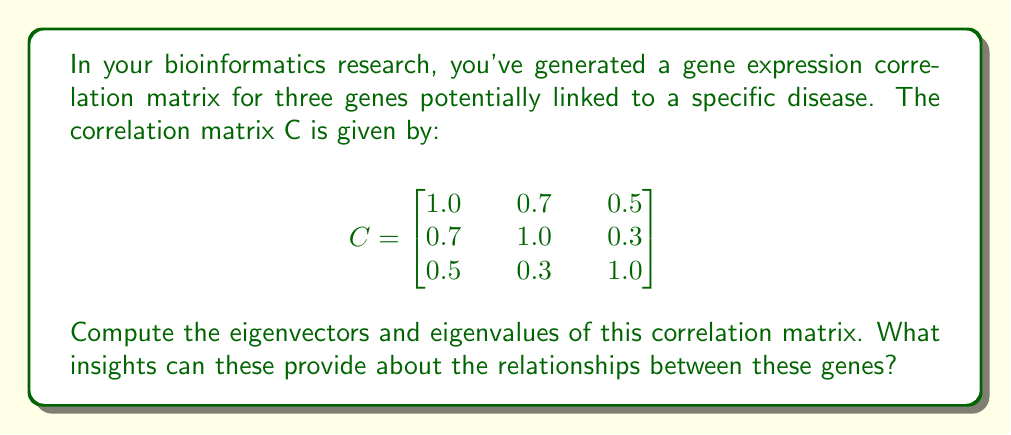Can you answer this question? To find the eigenvectors and eigenvalues of the correlation matrix C, we follow these steps:

1) First, we need to solve the characteristic equation:
   $$\det(C - \lambda I) = 0$$
   
   Where I is the 3x3 identity matrix and λ represents the eigenvalues.

2) Expanding the determinant:
   $$\begin{vmatrix}
   1-\lambda & 0.7 & 0.5 \\
   0.7 & 1-\lambda & 0.3 \\
   0.5 & 0.3 & 1-\lambda
   \end{vmatrix} = 0$$

3) This gives us the characteristic polynomial:
   $$(1-\lambda)^3 + 2(0.7)(0.5)(0.3) - (1-\lambda)(0.7^2 + 0.5^2 + 0.3^2) = 0$$
   $$-\lambda^3 + 3\lambda^2 - 2.62\lambda + 0.621 = 0$$

4) Solving this cubic equation (using a computer algebra system or numerical methods), we get the eigenvalues:
   $$\lambda_1 \approx 2.1543, \lambda_2 \approx 0.5406, \lambda_3 \approx 0.3051$$

5) For each eigenvalue, we solve $(C - \lambda_i I)\vec{v} = \vec{0}$ to find the corresponding eigenvector.

6) For $\lambda_1 \approx 2.1543$:
   $$\begin{bmatrix}
   -1.1543 & 0.7 & 0.5 \\
   0.7 & -1.1543 & 0.3 \\
   0.5 & 0.3 & -1.1543
   \end{bmatrix}\vec{v_1} = \vec{0}$$
   
   Solving this gives us (after normalization):
   $$\vec{v_1} \approx [0.6015, 0.5613, 0.5681]^T$$

7) Similarly, for $\lambda_2 \approx 0.5406$ and $\lambda_3 \approx 0.3051$, we get:
   $$\vec{v_2} \approx [-0.2729, -0.6533, 0.7066]^T$$
   $$\vec{v_3} \approx [0.7501, -0.5081, -0.4231]^T$$

Interpretation: The largest eigenvalue (2.1543) and its corresponding eigenvector represent the principal direction of correlation in the data. The components of this eigenvector are all positive and relatively close in magnitude, suggesting that all three genes contribute similarly to the main pattern of expression. The smaller eigenvalues and their eigenvectors represent secondary patterns of variation in the data, potentially highlighting more subtle relationships between the genes.
Answer: Eigenvalues: $\lambda_1 \approx 2.1543, \lambda_2 \approx 0.5406, \lambda_3 \approx 0.3051$
Eigenvectors: $\vec{v_1} \approx [0.6015, 0.5613, 0.5681]^T, \vec{v_2} \approx [-0.2729, -0.6533, 0.7066]^T, \vec{v_3} \approx [0.7501, -0.5081, -0.4231]^T$ 